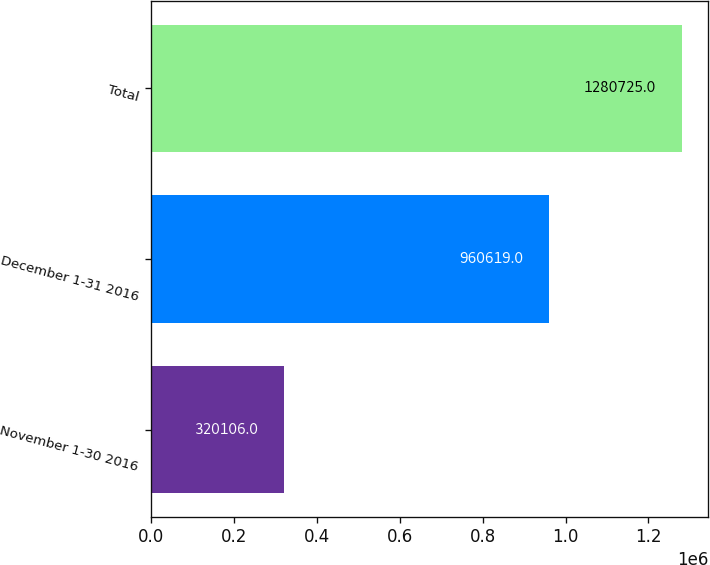Convert chart to OTSL. <chart><loc_0><loc_0><loc_500><loc_500><bar_chart><fcel>November 1-30 2016<fcel>December 1-31 2016<fcel>Total<nl><fcel>320106<fcel>960619<fcel>1.28072e+06<nl></chart> 